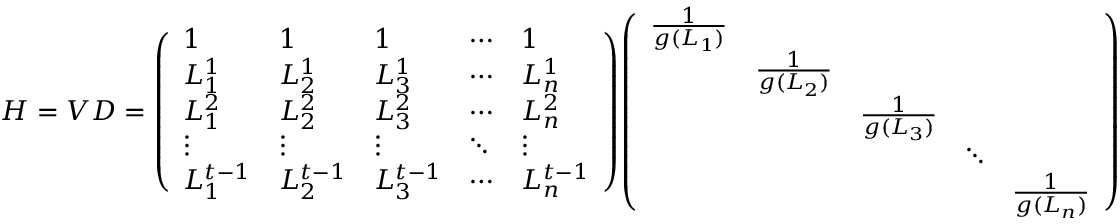<formula> <loc_0><loc_0><loc_500><loc_500>H = V D = { \left ( \begin{array} { l l l l l } { 1 } & { 1 } & { 1 } & { \cdots } & { 1 } \\ { L _ { 1 } ^ { 1 } } & { L _ { 2 } ^ { 1 } } & { L _ { 3 } ^ { 1 } } & { \cdots } & { L _ { n } ^ { 1 } } \\ { L _ { 1 } ^ { 2 } } & { L _ { 2 } ^ { 2 } } & { L _ { 3 } ^ { 2 } } & { \cdots } & { L _ { n } ^ { 2 } } \\ { \vdots } & { \vdots } & { \vdots } & { \ddots } & { \vdots } \\ { L _ { 1 } ^ { t - 1 } } & { L _ { 2 } ^ { t - 1 } } & { L _ { 3 } ^ { t - 1 } } & { \cdots } & { L _ { n } ^ { t - 1 } } \end{array} \right ) } { \left ( \begin{array} { l l l l l } { { \frac { 1 } { g ( L _ { 1 } ) } } } & & & & \\ & { { \frac { 1 } { g ( L _ { 2 } ) } } } & & & \\ & & { { \frac { 1 } { g ( L _ { 3 } ) } } } & & \\ & & & { \ddots } & \\ & & & & { { \frac { 1 } { g ( L _ { n } ) } } } \end{array} \right ) }</formula> 